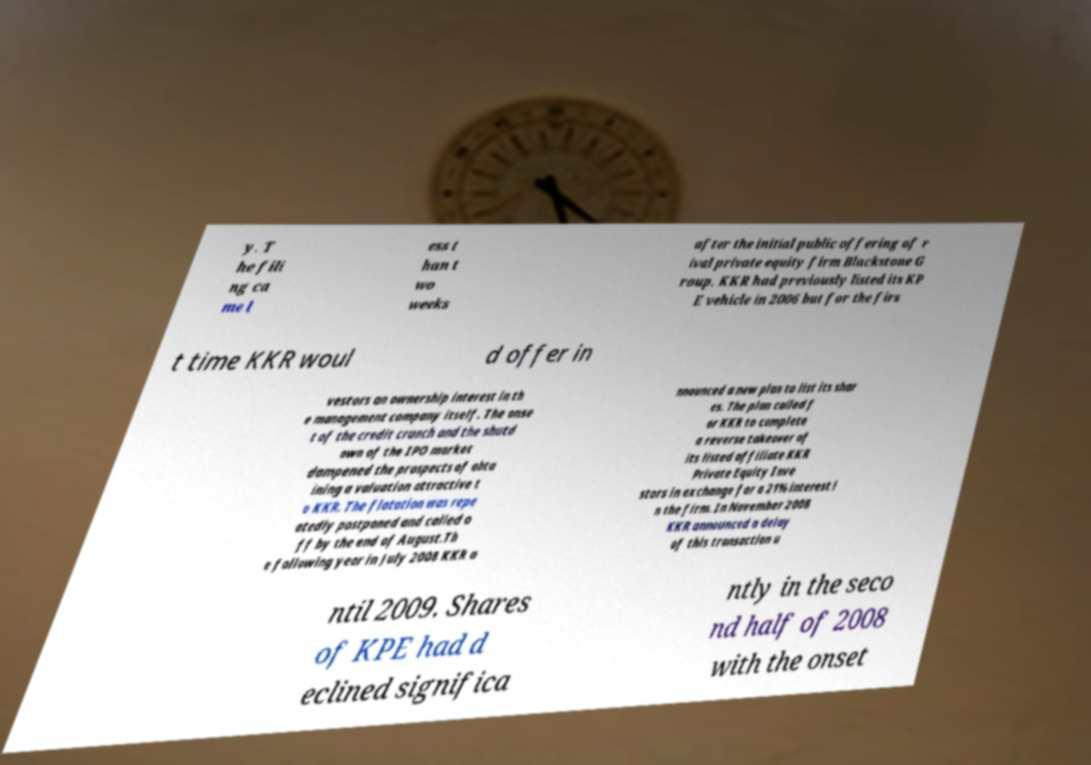Can you read and provide the text displayed in the image?This photo seems to have some interesting text. Can you extract and type it out for me? y. T he fili ng ca me l ess t han t wo weeks after the initial public offering of r ival private equity firm Blackstone G roup. KKR had previously listed its KP E vehicle in 2006 but for the firs t time KKR woul d offer in vestors an ownership interest in th e management company itself. The onse t of the credit crunch and the shutd own of the IPO market dampened the prospects of obta ining a valuation attractive t o KKR. The flotation was repe atedly postponed and called o ff by the end of August.Th e following year in July 2008 KKR a nnounced a new plan to list its shar es. The plan called f or KKR to complete a reverse takeover of its listed affiliate KKR Private Equity Inve stors in exchange for a 21% interest i n the firm. In November 2008 KKR announced a delay of this transaction u ntil 2009. Shares of KPE had d eclined significa ntly in the seco nd half of 2008 with the onset 